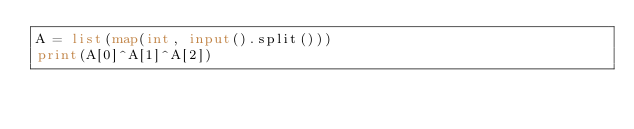<code> <loc_0><loc_0><loc_500><loc_500><_Python_>A = list(map(int, input().split()))
print(A[0]^A[1]^A[2])</code> 